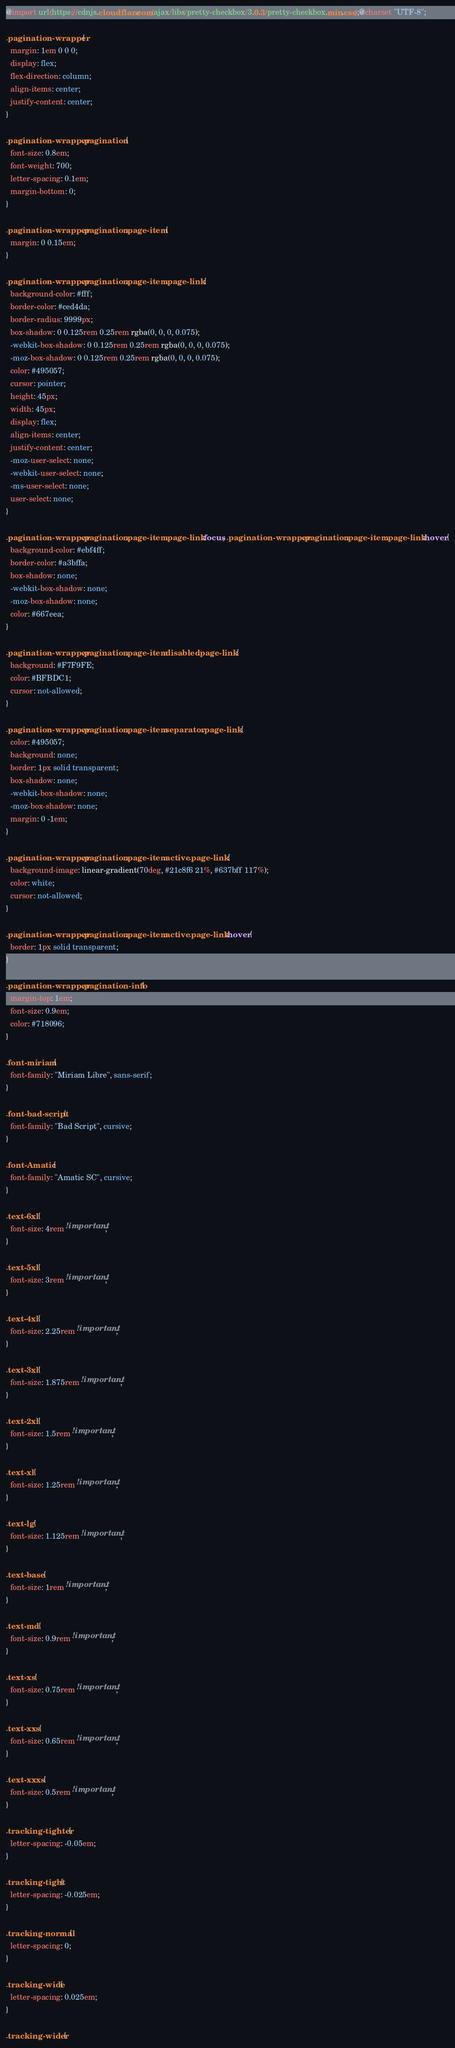Convert code to text. <code><loc_0><loc_0><loc_500><loc_500><_CSS_>@import url(https://cdnjs.cloudflare.com/ajax/libs/pretty-checkbox/3.0.3/pretty-checkbox.min.css);@charset "UTF-8";

.pagination-wrapper {
  margin: 1em 0 0 0;
  display: flex;
  flex-direction: column;
  align-items: center;
  justify-content: center;
}

.pagination-wrapper .pagination {
  font-size: 0.8em;
  font-weight: 700;
  letter-spacing: 0.1em;
  margin-bottom: 0;
}

.pagination-wrapper .pagination .page-item {
  margin: 0 0.15em;
}

.pagination-wrapper .pagination .page-item .page-link {
  background-color: #fff;
  border-color: #ced4da;
  border-radius: 9999px;
  box-shadow: 0 0.125rem 0.25rem rgba(0, 0, 0, 0.075);
  -webkit-box-shadow: 0 0.125rem 0.25rem rgba(0, 0, 0, 0.075);
  -moz-box-shadow: 0 0.125rem 0.25rem rgba(0, 0, 0, 0.075);
  color: #495057;
  cursor: pointer;
  height: 45px;
  width: 45px;
  display: flex;
  align-items: center;
  justify-content: center;
  -moz-user-select: none;
  -webkit-user-select: none;
  -ms-user-select: none;
  user-select: none;
}

.pagination-wrapper .pagination .page-item .page-link:focus, .pagination-wrapper .pagination .page-item .page-link:hover {
  background-color: #ebf4ff;
  border-color: #a3bffa;
  box-shadow: none;
  -webkit-box-shadow: none;
  -moz-box-shadow: none;
  color: #667eea;
}

.pagination-wrapper .pagination .page-item.disabled .page-link {
  background: #F7F9FE;
  color: #BFBDC1;
  cursor: not-allowed;
}

.pagination-wrapper .pagination .page-item.separator .page-link {
  color: #495057;
  background: none;
  border: 1px solid transparent;
  box-shadow: none;
  -webkit-box-shadow: none;
  -moz-box-shadow: none;
  margin: 0 -1em;
}

.pagination-wrapper .pagination .page-item.active .page-link {
  background-image: linear-gradient(70deg, #21c8f6 21%, #637bff 117%);
  color: white;
  cursor: not-allowed;
}

.pagination-wrapper .pagination .page-item.active .page-link:hover {
  border: 1px solid transparent;
}

.pagination-wrapper .pagination-info {
  margin-top: 1em;
  font-size: 0.9em;
  color: #718096;
}

.font-miriam {
  font-family: "Miriam Libre", sans-serif;
}

.font-bad-script {
  font-family: "Bad Script", cursive;
}

.font-Amatic {
  font-family: "Amatic SC", cursive;
}

.text-6xl {
  font-size: 4rem !important;
}

.text-5xl {
  font-size: 3rem !important;
}

.text-4xl {
  font-size: 2.25rem !important;
}

.text-3xl {
  font-size: 1.875rem !important;
}

.text-2xl {
  font-size: 1.5rem !important;
}

.text-xl {
  font-size: 1.25rem !important;
}

.text-lg {
  font-size: 1.125rem !important;
}

.text-base {
  font-size: 1rem !important;
}

.text-md {
  font-size: 0.9rem !important;
}

.text-xs {
  font-size: 0.75rem !important;
}

.text-xxs {
  font-size: 0.65rem !important;
}

.text-xxxs {
  font-size: 0.5rem !important;
}

.tracking-tighter {
  letter-spacing: -0.05em;
}

.tracking-tight {
  letter-spacing: -0.025em;
}

.tracking-normal {
  letter-spacing: 0;
}

.tracking-wide {
  letter-spacing: 0.025em;
}

.tracking-wider {</code> 